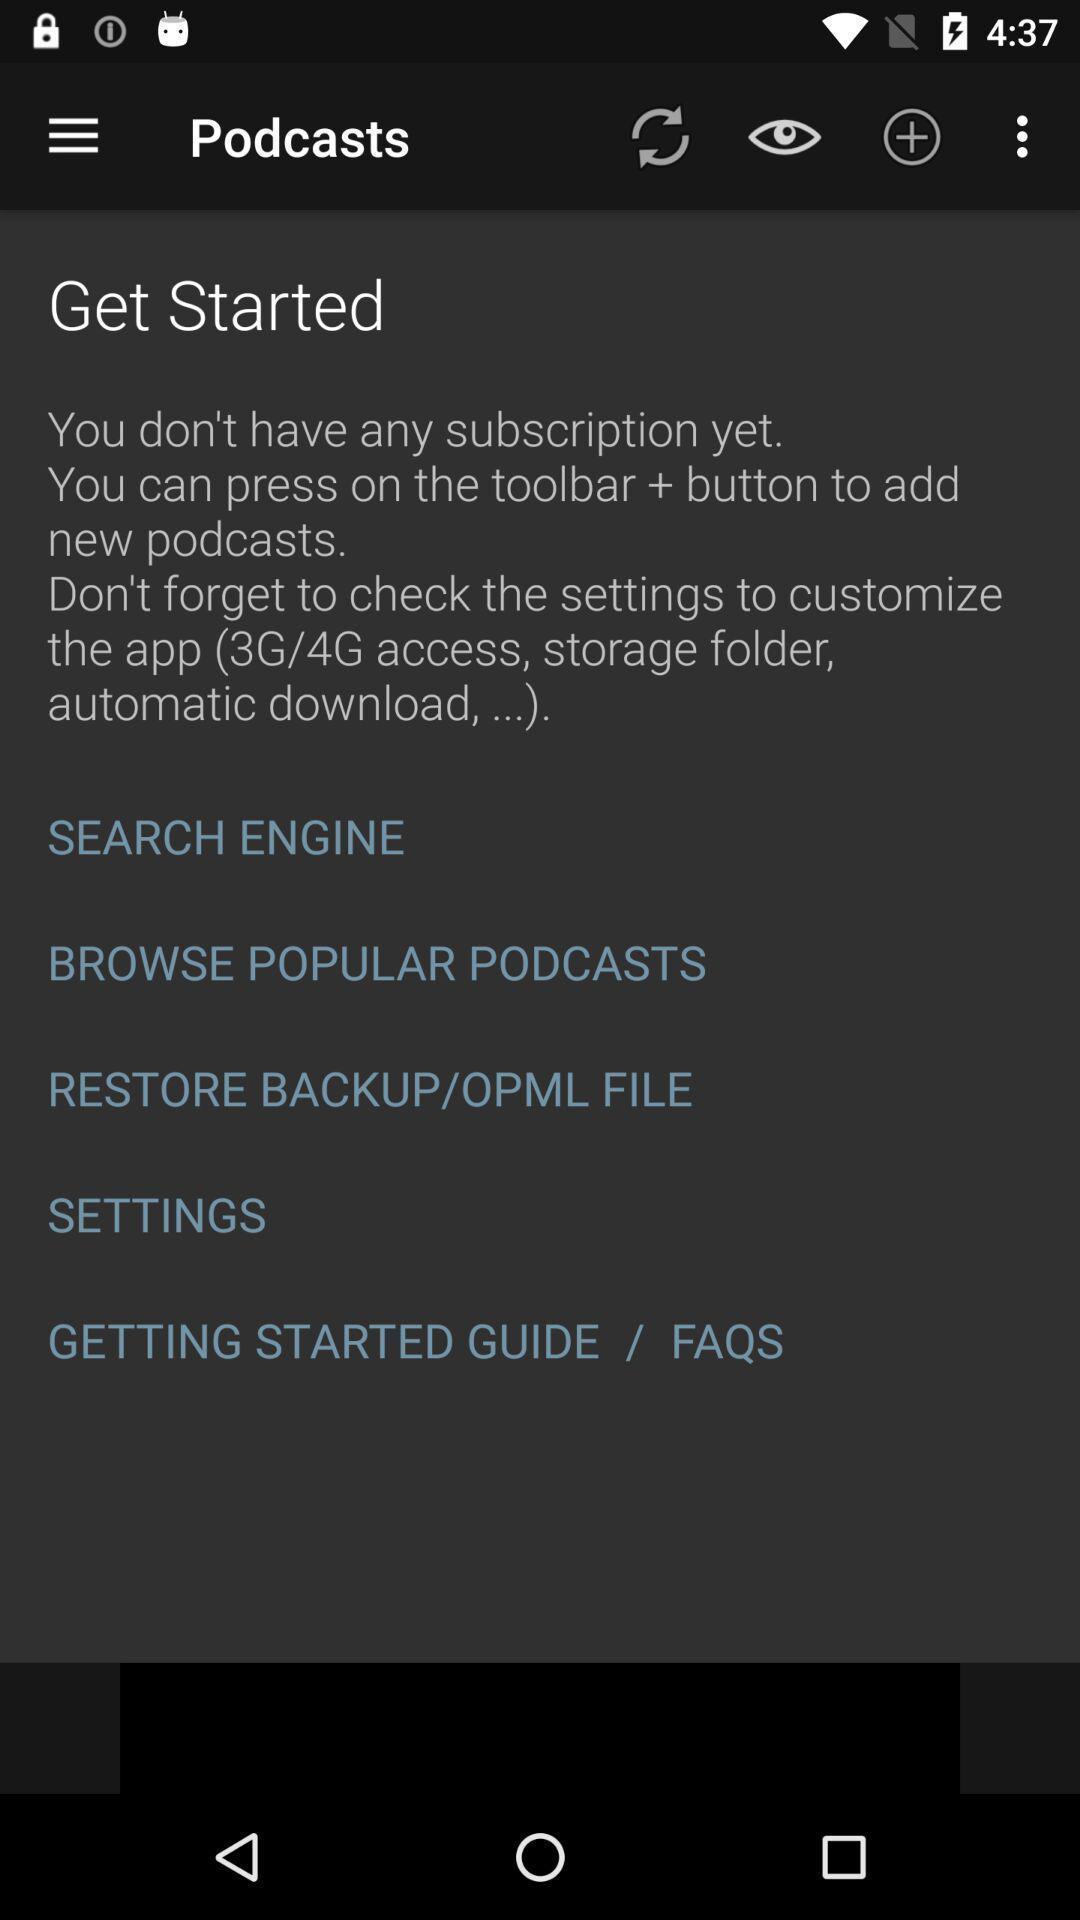What can you discern from this picture? Welcome page with different options for the audio editing app. 